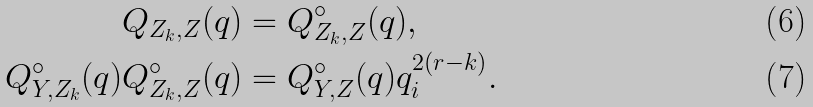Convert formula to latex. <formula><loc_0><loc_0><loc_500><loc_500>Q _ { Z _ { k } , Z } ( q ) & = Q _ { Z _ { k } , Z } ^ { \circ } ( q ) , \\ Q _ { Y , Z _ { k } } ^ { \circ } ( q ) Q _ { Z _ { k } , Z } ^ { \circ } ( q ) & = Q _ { Y , Z } ^ { \circ } ( q ) q _ { i } ^ { 2 ( r - k ) } .</formula> 